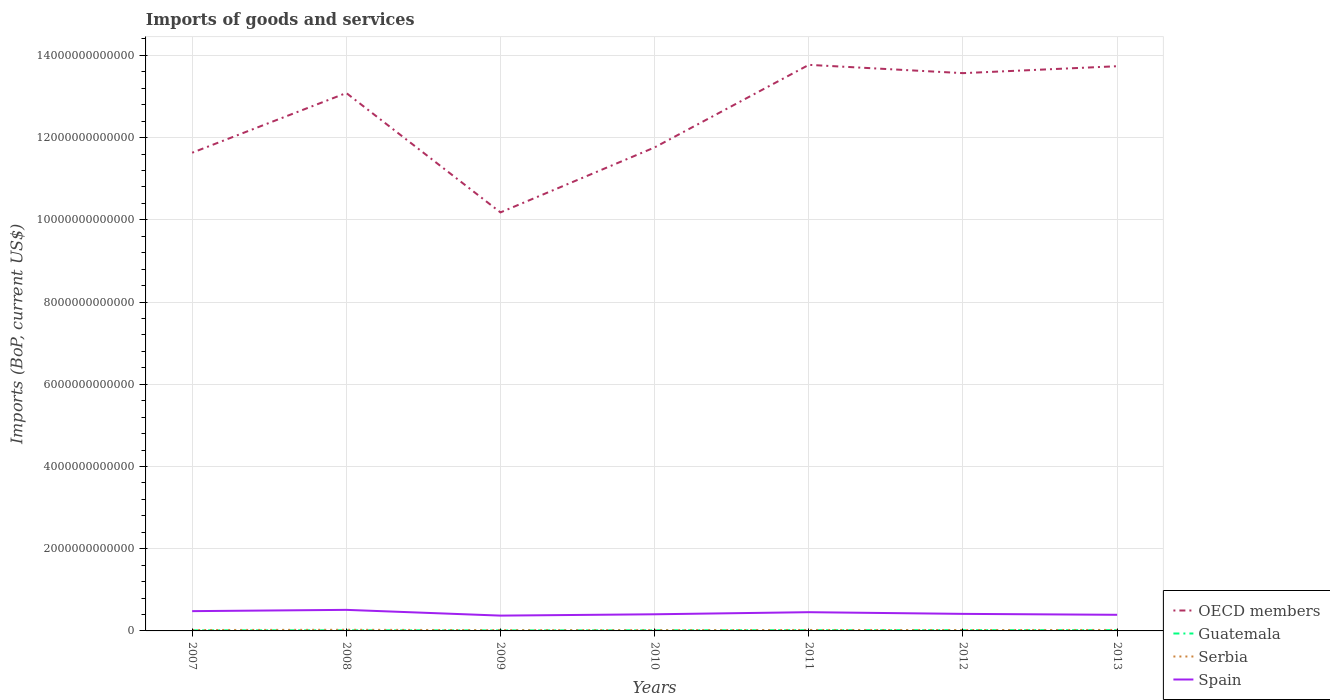Is the number of lines equal to the number of legend labels?
Give a very brief answer. Yes. Across all years, what is the maximum amount spent on imports in Guatemala?
Provide a succinct answer. 1.28e+1. What is the total amount spent on imports in Serbia in the graph?
Give a very brief answer. 2.93e+09. What is the difference between the highest and the second highest amount spent on imports in Spain?
Provide a short and direct response. 1.40e+11. What is the difference between the highest and the lowest amount spent on imports in Guatemala?
Give a very brief answer. 3. Is the amount spent on imports in Serbia strictly greater than the amount spent on imports in Guatemala over the years?
Provide a succinct answer. No. How many lines are there?
Your answer should be compact. 4. How many years are there in the graph?
Provide a succinct answer. 7. What is the difference between two consecutive major ticks on the Y-axis?
Ensure brevity in your answer.  2.00e+12. Are the values on the major ticks of Y-axis written in scientific E-notation?
Give a very brief answer. No. Does the graph contain any zero values?
Ensure brevity in your answer.  No. How are the legend labels stacked?
Give a very brief answer. Vertical. What is the title of the graph?
Your answer should be compact. Imports of goods and services. What is the label or title of the X-axis?
Ensure brevity in your answer.  Years. What is the label or title of the Y-axis?
Offer a terse response. Imports (BoP, current US$). What is the Imports (BoP, current US$) of OECD members in 2007?
Offer a terse response. 1.16e+13. What is the Imports (BoP, current US$) of Guatemala in 2007?
Provide a succinct answer. 1.45e+1. What is the Imports (BoP, current US$) of Serbia in 2007?
Ensure brevity in your answer.  2.19e+1. What is the Imports (BoP, current US$) of Spain in 2007?
Your response must be concise. 4.81e+11. What is the Imports (BoP, current US$) of OECD members in 2008?
Keep it short and to the point. 1.31e+13. What is the Imports (BoP, current US$) of Guatemala in 2008?
Offer a terse response. 1.55e+1. What is the Imports (BoP, current US$) of Serbia in 2008?
Provide a succinct answer. 2.78e+1. What is the Imports (BoP, current US$) of Spain in 2008?
Make the answer very short. 5.12e+11. What is the Imports (BoP, current US$) of OECD members in 2009?
Offer a terse response. 1.02e+13. What is the Imports (BoP, current US$) of Guatemala in 2009?
Provide a short and direct response. 1.28e+1. What is the Imports (BoP, current US$) of Serbia in 2009?
Offer a very short reply. 1.89e+1. What is the Imports (BoP, current US$) in Spain in 2009?
Ensure brevity in your answer.  3.72e+11. What is the Imports (BoP, current US$) of OECD members in 2010?
Offer a terse response. 1.18e+13. What is the Imports (BoP, current US$) of Guatemala in 2010?
Provide a short and direct response. 1.52e+1. What is the Imports (BoP, current US$) of Serbia in 2010?
Ensure brevity in your answer.  1.94e+1. What is the Imports (BoP, current US$) in Spain in 2010?
Your response must be concise. 4.05e+11. What is the Imports (BoP, current US$) of OECD members in 2011?
Offer a very short reply. 1.38e+13. What is the Imports (BoP, current US$) of Guatemala in 2011?
Make the answer very short. 1.80e+1. What is the Imports (BoP, current US$) in Serbia in 2011?
Offer a terse response. 2.31e+1. What is the Imports (BoP, current US$) of Spain in 2011?
Provide a short and direct response. 4.56e+11. What is the Imports (BoP, current US$) in OECD members in 2012?
Make the answer very short. 1.36e+13. What is the Imports (BoP, current US$) of Guatemala in 2012?
Provide a short and direct response. 1.84e+1. What is the Imports (BoP, current US$) of Serbia in 2012?
Your response must be concise. 2.19e+1. What is the Imports (BoP, current US$) in Spain in 2012?
Your response must be concise. 4.15e+11. What is the Imports (BoP, current US$) in OECD members in 2013?
Provide a short and direct response. 1.37e+13. What is the Imports (BoP, current US$) in Guatemala in 2013?
Offer a very short reply. 1.91e+1. What is the Imports (BoP, current US$) of Serbia in 2013?
Your answer should be compact. 2.37e+1. What is the Imports (BoP, current US$) of Spain in 2013?
Provide a succinct answer. 3.92e+11. Across all years, what is the maximum Imports (BoP, current US$) of OECD members?
Ensure brevity in your answer.  1.38e+13. Across all years, what is the maximum Imports (BoP, current US$) of Guatemala?
Your answer should be very brief. 1.91e+1. Across all years, what is the maximum Imports (BoP, current US$) in Serbia?
Your response must be concise. 2.78e+1. Across all years, what is the maximum Imports (BoP, current US$) in Spain?
Your response must be concise. 5.12e+11. Across all years, what is the minimum Imports (BoP, current US$) of OECD members?
Provide a short and direct response. 1.02e+13. Across all years, what is the minimum Imports (BoP, current US$) of Guatemala?
Ensure brevity in your answer.  1.28e+1. Across all years, what is the minimum Imports (BoP, current US$) of Serbia?
Make the answer very short. 1.89e+1. Across all years, what is the minimum Imports (BoP, current US$) of Spain?
Make the answer very short. 3.72e+11. What is the total Imports (BoP, current US$) of OECD members in the graph?
Offer a very short reply. 8.77e+13. What is the total Imports (BoP, current US$) in Guatemala in the graph?
Ensure brevity in your answer.  1.13e+11. What is the total Imports (BoP, current US$) in Serbia in the graph?
Give a very brief answer. 1.57e+11. What is the total Imports (BoP, current US$) of Spain in the graph?
Offer a very short reply. 3.03e+12. What is the difference between the Imports (BoP, current US$) of OECD members in 2007 and that in 2008?
Provide a succinct answer. -1.45e+12. What is the difference between the Imports (BoP, current US$) of Guatemala in 2007 and that in 2008?
Make the answer very short. -9.53e+08. What is the difference between the Imports (BoP, current US$) in Serbia in 2007 and that in 2008?
Provide a short and direct response. -5.88e+09. What is the difference between the Imports (BoP, current US$) in Spain in 2007 and that in 2008?
Provide a succinct answer. -3.09e+1. What is the difference between the Imports (BoP, current US$) of OECD members in 2007 and that in 2009?
Your answer should be very brief. 1.45e+12. What is the difference between the Imports (BoP, current US$) of Guatemala in 2007 and that in 2009?
Offer a very short reply. 1.74e+09. What is the difference between the Imports (BoP, current US$) of Serbia in 2007 and that in 2009?
Give a very brief answer. 2.93e+09. What is the difference between the Imports (BoP, current US$) of Spain in 2007 and that in 2009?
Provide a succinct answer. 1.09e+11. What is the difference between the Imports (BoP, current US$) of OECD members in 2007 and that in 2010?
Your answer should be very brief. -1.30e+11. What is the difference between the Imports (BoP, current US$) of Guatemala in 2007 and that in 2010?
Provide a short and direct response. -7.02e+08. What is the difference between the Imports (BoP, current US$) in Serbia in 2007 and that in 2010?
Provide a succinct answer. 2.47e+09. What is the difference between the Imports (BoP, current US$) in Spain in 2007 and that in 2010?
Provide a succinct answer. 7.66e+1. What is the difference between the Imports (BoP, current US$) in OECD members in 2007 and that in 2011?
Give a very brief answer. -2.14e+12. What is the difference between the Imports (BoP, current US$) in Guatemala in 2007 and that in 2011?
Your response must be concise. -3.49e+09. What is the difference between the Imports (BoP, current US$) in Serbia in 2007 and that in 2011?
Your answer should be compact. -1.24e+09. What is the difference between the Imports (BoP, current US$) in Spain in 2007 and that in 2011?
Provide a short and direct response. 2.55e+1. What is the difference between the Imports (BoP, current US$) of OECD members in 2007 and that in 2012?
Offer a very short reply. -1.94e+12. What is the difference between the Imports (BoP, current US$) in Guatemala in 2007 and that in 2012?
Make the answer very short. -3.87e+09. What is the difference between the Imports (BoP, current US$) in Serbia in 2007 and that in 2012?
Your answer should be compact. 1.40e+07. What is the difference between the Imports (BoP, current US$) in Spain in 2007 and that in 2012?
Offer a terse response. 6.68e+1. What is the difference between the Imports (BoP, current US$) in OECD members in 2007 and that in 2013?
Ensure brevity in your answer.  -2.10e+12. What is the difference between the Imports (BoP, current US$) in Guatemala in 2007 and that in 2013?
Offer a very short reply. -4.60e+09. What is the difference between the Imports (BoP, current US$) of Serbia in 2007 and that in 2013?
Keep it short and to the point. -1.78e+09. What is the difference between the Imports (BoP, current US$) in Spain in 2007 and that in 2013?
Provide a short and direct response. 8.90e+1. What is the difference between the Imports (BoP, current US$) in OECD members in 2008 and that in 2009?
Make the answer very short. 2.90e+12. What is the difference between the Imports (BoP, current US$) in Guatemala in 2008 and that in 2009?
Give a very brief answer. 2.69e+09. What is the difference between the Imports (BoP, current US$) of Serbia in 2008 and that in 2009?
Give a very brief answer. 8.80e+09. What is the difference between the Imports (BoP, current US$) of Spain in 2008 and that in 2009?
Your answer should be compact. 1.40e+11. What is the difference between the Imports (BoP, current US$) of OECD members in 2008 and that in 2010?
Offer a very short reply. 1.32e+12. What is the difference between the Imports (BoP, current US$) in Guatemala in 2008 and that in 2010?
Your answer should be very brief. 2.51e+08. What is the difference between the Imports (BoP, current US$) in Serbia in 2008 and that in 2010?
Offer a very short reply. 8.35e+09. What is the difference between the Imports (BoP, current US$) of Spain in 2008 and that in 2010?
Give a very brief answer. 1.07e+11. What is the difference between the Imports (BoP, current US$) in OECD members in 2008 and that in 2011?
Offer a terse response. -6.85e+11. What is the difference between the Imports (BoP, current US$) in Guatemala in 2008 and that in 2011?
Give a very brief answer. -2.53e+09. What is the difference between the Imports (BoP, current US$) of Serbia in 2008 and that in 2011?
Your answer should be compact. 4.63e+09. What is the difference between the Imports (BoP, current US$) in Spain in 2008 and that in 2011?
Ensure brevity in your answer.  5.64e+1. What is the difference between the Imports (BoP, current US$) in OECD members in 2008 and that in 2012?
Your answer should be compact. -4.83e+11. What is the difference between the Imports (BoP, current US$) of Guatemala in 2008 and that in 2012?
Provide a short and direct response. -2.91e+09. What is the difference between the Imports (BoP, current US$) in Serbia in 2008 and that in 2012?
Your response must be concise. 5.89e+09. What is the difference between the Imports (BoP, current US$) in Spain in 2008 and that in 2012?
Your response must be concise. 9.77e+1. What is the difference between the Imports (BoP, current US$) of OECD members in 2008 and that in 2013?
Make the answer very short. -6.52e+11. What is the difference between the Imports (BoP, current US$) in Guatemala in 2008 and that in 2013?
Provide a succinct answer. -3.65e+09. What is the difference between the Imports (BoP, current US$) of Serbia in 2008 and that in 2013?
Provide a short and direct response. 4.10e+09. What is the difference between the Imports (BoP, current US$) of Spain in 2008 and that in 2013?
Ensure brevity in your answer.  1.20e+11. What is the difference between the Imports (BoP, current US$) in OECD members in 2009 and that in 2010?
Provide a short and direct response. -1.58e+12. What is the difference between the Imports (BoP, current US$) in Guatemala in 2009 and that in 2010?
Offer a very short reply. -2.44e+09. What is the difference between the Imports (BoP, current US$) in Serbia in 2009 and that in 2010?
Keep it short and to the point. -4.57e+08. What is the difference between the Imports (BoP, current US$) of Spain in 2009 and that in 2010?
Your answer should be compact. -3.24e+1. What is the difference between the Imports (BoP, current US$) in OECD members in 2009 and that in 2011?
Your answer should be compact. -3.59e+12. What is the difference between the Imports (BoP, current US$) of Guatemala in 2009 and that in 2011?
Give a very brief answer. -5.22e+09. What is the difference between the Imports (BoP, current US$) in Serbia in 2009 and that in 2011?
Offer a terse response. -4.17e+09. What is the difference between the Imports (BoP, current US$) of Spain in 2009 and that in 2011?
Ensure brevity in your answer.  -8.35e+1. What is the difference between the Imports (BoP, current US$) of OECD members in 2009 and that in 2012?
Make the answer very short. -3.39e+12. What is the difference between the Imports (BoP, current US$) in Guatemala in 2009 and that in 2012?
Offer a very short reply. -5.60e+09. What is the difference between the Imports (BoP, current US$) of Serbia in 2009 and that in 2012?
Keep it short and to the point. -2.91e+09. What is the difference between the Imports (BoP, current US$) of Spain in 2009 and that in 2012?
Provide a short and direct response. -4.21e+1. What is the difference between the Imports (BoP, current US$) of OECD members in 2009 and that in 2013?
Your response must be concise. -3.56e+12. What is the difference between the Imports (BoP, current US$) in Guatemala in 2009 and that in 2013?
Provide a succinct answer. -6.34e+09. What is the difference between the Imports (BoP, current US$) in Serbia in 2009 and that in 2013?
Your answer should be compact. -4.71e+09. What is the difference between the Imports (BoP, current US$) in Spain in 2009 and that in 2013?
Provide a short and direct response. -1.99e+1. What is the difference between the Imports (BoP, current US$) of OECD members in 2010 and that in 2011?
Ensure brevity in your answer.  -2.01e+12. What is the difference between the Imports (BoP, current US$) of Guatemala in 2010 and that in 2011?
Give a very brief answer. -2.79e+09. What is the difference between the Imports (BoP, current US$) of Serbia in 2010 and that in 2011?
Ensure brevity in your answer.  -3.71e+09. What is the difference between the Imports (BoP, current US$) in Spain in 2010 and that in 2011?
Offer a terse response. -5.10e+1. What is the difference between the Imports (BoP, current US$) in OECD members in 2010 and that in 2012?
Make the answer very short. -1.81e+12. What is the difference between the Imports (BoP, current US$) of Guatemala in 2010 and that in 2012?
Your response must be concise. -3.16e+09. What is the difference between the Imports (BoP, current US$) in Serbia in 2010 and that in 2012?
Your answer should be very brief. -2.46e+09. What is the difference between the Imports (BoP, current US$) of Spain in 2010 and that in 2012?
Offer a very short reply. -9.73e+09. What is the difference between the Imports (BoP, current US$) in OECD members in 2010 and that in 2013?
Make the answer very short. -1.97e+12. What is the difference between the Imports (BoP, current US$) in Guatemala in 2010 and that in 2013?
Give a very brief answer. -3.90e+09. What is the difference between the Imports (BoP, current US$) of Serbia in 2010 and that in 2013?
Make the answer very short. -4.25e+09. What is the difference between the Imports (BoP, current US$) in Spain in 2010 and that in 2013?
Keep it short and to the point. 1.25e+1. What is the difference between the Imports (BoP, current US$) in OECD members in 2011 and that in 2012?
Give a very brief answer. 2.02e+11. What is the difference between the Imports (BoP, current US$) of Guatemala in 2011 and that in 2012?
Offer a terse response. -3.78e+08. What is the difference between the Imports (BoP, current US$) in Serbia in 2011 and that in 2012?
Offer a terse response. 1.26e+09. What is the difference between the Imports (BoP, current US$) in Spain in 2011 and that in 2012?
Keep it short and to the point. 4.13e+1. What is the difference between the Imports (BoP, current US$) of OECD members in 2011 and that in 2013?
Offer a very short reply. 3.33e+1. What is the difference between the Imports (BoP, current US$) in Guatemala in 2011 and that in 2013?
Ensure brevity in your answer.  -1.12e+09. What is the difference between the Imports (BoP, current US$) in Serbia in 2011 and that in 2013?
Provide a succinct answer. -5.34e+08. What is the difference between the Imports (BoP, current US$) in Spain in 2011 and that in 2013?
Keep it short and to the point. 6.35e+1. What is the difference between the Imports (BoP, current US$) in OECD members in 2012 and that in 2013?
Ensure brevity in your answer.  -1.68e+11. What is the difference between the Imports (BoP, current US$) in Guatemala in 2012 and that in 2013?
Provide a succinct answer. -7.39e+08. What is the difference between the Imports (BoP, current US$) of Serbia in 2012 and that in 2013?
Your response must be concise. -1.79e+09. What is the difference between the Imports (BoP, current US$) in Spain in 2012 and that in 2013?
Your answer should be compact. 2.22e+1. What is the difference between the Imports (BoP, current US$) of OECD members in 2007 and the Imports (BoP, current US$) of Guatemala in 2008?
Your answer should be compact. 1.16e+13. What is the difference between the Imports (BoP, current US$) in OECD members in 2007 and the Imports (BoP, current US$) in Serbia in 2008?
Make the answer very short. 1.16e+13. What is the difference between the Imports (BoP, current US$) in OECD members in 2007 and the Imports (BoP, current US$) in Spain in 2008?
Keep it short and to the point. 1.11e+13. What is the difference between the Imports (BoP, current US$) in Guatemala in 2007 and the Imports (BoP, current US$) in Serbia in 2008?
Provide a short and direct response. -1.32e+1. What is the difference between the Imports (BoP, current US$) of Guatemala in 2007 and the Imports (BoP, current US$) of Spain in 2008?
Provide a succinct answer. -4.98e+11. What is the difference between the Imports (BoP, current US$) in Serbia in 2007 and the Imports (BoP, current US$) in Spain in 2008?
Your answer should be compact. -4.90e+11. What is the difference between the Imports (BoP, current US$) of OECD members in 2007 and the Imports (BoP, current US$) of Guatemala in 2009?
Give a very brief answer. 1.16e+13. What is the difference between the Imports (BoP, current US$) in OECD members in 2007 and the Imports (BoP, current US$) in Serbia in 2009?
Your answer should be very brief. 1.16e+13. What is the difference between the Imports (BoP, current US$) in OECD members in 2007 and the Imports (BoP, current US$) in Spain in 2009?
Provide a succinct answer. 1.13e+13. What is the difference between the Imports (BoP, current US$) in Guatemala in 2007 and the Imports (BoP, current US$) in Serbia in 2009?
Ensure brevity in your answer.  -4.44e+09. What is the difference between the Imports (BoP, current US$) of Guatemala in 2007 and the Imports (BoP, current US$) of Spain in 2009?
Give a very brief answer. -3.58e+11. What is the difference between the Imports (BoP, current US$) in Serbia in 2007 and the Imports (BoP, current US$) in Spain in 2009?
Ensure brevity in your answer.  -3.51e+11. What is the difference between the Imports (BoP, current US$) of OECD members in 2007 and the Imports (BoP, current US$) of Guatemala in 2010?
Keep it short and to the point. 1.16e+13. What is the difference between the Imports (BoP, current US$) in OECD members in 2007 and the Imports (BoP, current US$) in Serbia in 2010?
Provide a short and direct response. 1.16e+13. What is the difference between the Imports (BoP, current US$) of OECD members in 2007 and the Imports (BoP, current US$) of Spain in 2010?
Your answer should be very brief. 1.12e+13. What is the difference between the Imports (BoP, current US$) of Guatemala in 2007 and the Imports (BoP, current US$) of Serbia in 2010?
Keep it short and to the point. -4.89e+09. What is the difference between the Imports (BoP, current US$) in Guatemala in 2007 and the Imports (BoP, current US$) in Spain in 2010?
Give a very brief answer. -3.90e+11. What is the difference between the Imports (BoP, current US$) in Serbia in 2007 and the Imports (BoP, current US$) in Spain in 2010?
Give a very brief answer. -3.83e+11. What is the difference between the Imports (BoP, current US$) in OECD members in 2007 and the Imports (BoP, current US$) in Guatemala in 2011?
Your answer should be very brief. 1.16e+13. What is the difference between the Imports (BoP, current US$) of OECD members in 2007 and the Imports (BoP, current US$) of Serbia in 2011?
Offer a very short reply. 1.16e+13. What is the difference between the Imports (BoP, current US$) of OECD members in 2007 and the Imports (BoP, current US$) of Spain in 2011?
Provide a succinct answer. 1.12e+13. What is the difference between the Imports (BoP, current US$) of Guatemala in 2007 and the Imports (BoP, current US$) of Serbia in 2011?
Your answer should be compact. -8.61e+09. What is the difference between the Imports (BoP, current US$) of Guatemala in 2007 and the Imports (BoP, current US$) of Spain in 2011?
Provide a succinct answer. -4.41e+11. What is the difference between the Imports (BoP, current US$) in Serbia in 2007 and the Imports (BoP, current US$) in Spain in 2011?
Your response must be concise. -4.34e+11. What is the difference between the Imports (BoP, current US$) in OECD members in 2007 and the Imports (BoP, current US$) in Guatemala in 2012?
Keep it short and to the point. 1.16e+13. What is the difference between the Imports (BoP, current US$) in OECD members in 2007 and the Imports (BoP, current US$) in Serbia in 2012?
Keep it short and to the point. 1.16e+13. What is the difference between the Imports (BoP, current US$) in OECD members in 2007 and the Imports (BoP, current US$) in Spain in 2012?
Provide a succinct answer. 1.12e+13. What is the difference between the Imports (BoP, current US$) of Guatemala in 2007 and the Imports (BoP, current US$) of Serbia in 2012?
Keep it short and to the point. -7.35e+09. What is the difference between the Imports (BoP, current US$) in Guatemala in 2007 and the Imports (BoP, current US$) in Spain in 2012?
Provide a short and direct response. -4.00e+11. What is the difference between the Imports (BoP, current US$) of Serbia in 2007 and the Imports (BoP, current US$) of Spain in 2012?
Offer a terse response. -3.93e+11. What is the difference between the Imports (BoP, current US$) in OECD members in 2007 and the Imports (BoP, current US$) in Guatemala in 2013?
Your answer should be compact. 1.16e+13. What is the difference between the Imports (BoP, current US$) of OECD members in 2007 and the Imports (BoP, current US$) of Serbia in 2013?
Offer a terse response. 1.16e+13. What is the difference between the Imports (BoP, current US$) of OECD members in 2007 and the Imports (BoP, current US$) of Spain in 2013?
Offer a terse response. 1.12e+13. What is the difference between the Imports (BoP, current US$) in Guatemala in 2007 and the Imports (BoP, current US$) in Serbia in 2013?
Your answer should be very brief. -9.14e+09. What is the difference between the Imports (BoP, current US$) of Guatemala in 2007 and the Imports (BoP, current US$) of Spain in 2013?
Your answer should be compact. -3.78e+11. What is the difference between the Imports (BoP, current US$) of Serbia in 2007 and the Imports (BoP, current US$) of Spain in 2013?
Your response must be concise. -3.70e+11. What is the difference between the Imports (BoP, current US$) in OECD members in 2008 and the Imports (BoP, current US$) in Guatemala in 2009?
Make the answer very short. 1.31e+13. What is the difference between the Imports (BoP, current US$) of OECD members in 2008 and the Imports (BoP, current US$) of Serbia in 2009?
Your answer should be very brief. 1.31e+13. What is the difference between the Imports (BoP, current US$) in OECD members in 2008 and the Imports (BoP, current US$) in Spain in 2009?
Your response must be concise. 1.27e+13. What is the difference between the Imports (BoP, current US$) in Guatemala in 2008 and the Imports (BoP, current US$) in Serbia in 2009?
Provide a succinct answer. -3.48e+09. What is the difference between the Imports (BoP, current US$) of Guatemala in 2008 and the Imports (BoP, current US$) of Spain in 2009?
Provide a succinct answer. -3.57e+11. What is the difference between the Imports (BoP, current US$) of Serbia in 2008 and the Imports (BoP, current US$) of Spain in 2009?
Make the answer very short. -3.45e+11. What is the difference between the Imports (BoP, current US$) of OECD members in 2008 and the Imports (BoP, current US$) of Guatemala in 2010?
Offer a terse response. 1.31e+13. What is the difference between the Imports (BoP, current US$) in OECD members in 2008 and the Imports (BoP, current US$) in Serbia in 2010?
Keep it short and to the point. 1.31e+13. What is the difference between the Imports (BoP, current US$) of OECD members in 2008 and the Imports (BoP, current US$) of Spain in 2010?
Keep it short and to the point. 1.27e+13. What is the difference between the Imports (BoP, current US$) of Guatemala in 2008 and the Imports (BoP, current US$) of Serbia in 2010?
Provide a short and direct response. -3.94e+09. What is the difference between the Imports (BoP, current US$) in Guatemala in 2008 and the Imports (BoP, current US$) in Spain in 2010?
Give a very brief answer. -3.89e+11. What is the difference between the Imports (BoP, current US$) in Serbia in 2008 and the Imports (BoP, current US$) in Spain in 2010?
Your response must be concise. -3.77e+11. What is the difference between the Imports (BoP, current US$) in OECD members in 2008 and the Imports (BoP, current US$) in Guatemala in 2011?
Keep it short and to the point. 1.31e+13. What is the difference between the Imports (BoP, current US$) of OECD members in 2008 and the Imports (BoP, current US$) of Serbia in 2011?
Your answer should be very brief. 1.31e+13. What is the difference between the Imports (BoP, current US$) of OECD members in 2008 and the Imports (BoP, current US$) of Spain in 2011?
Your answer should be compact. 1.26e+13. What is the difference between the Imports (BoP, current US$) of Guatemala in 2008 and the Imports (BoP, current US$) of Serbia in 2011?
Make the answer very short. -7.65e+09. What is the difference between the Imports (BoP, current US$) of Guatemala in 2008 and the Imports (BoP, current US$) of Spain in 2011?
Your answer should be very brief. -4.40e+11. What is the difference between the Imports (BoP, current US$) of Serbia in 2008 and the Imports (BoP, current US$) of Spain in 2011?
Ensure brevity in your answer.  -4.28e+11. What is the difference between the Imports (BoP, current US$) in OECD members in 2008 and the Imports (BoP, current US$) in Guatemala in 2012?
Keep it short and to the point. 1.31e+13. What is the difference between the Imports (BoP, current US$) of OECD members in 2008 and the Imports (BoP, current US$) of Serbia in 2012?
Your answer should be very brief. 1.31e+13. What is the difference between the Imports (BoP, current US$) in OECD members in 2008 and the Imports (BoP, current US$) in Spain in 2012?
Your response must be concise. 1.27e+13. What is the difference between the Imports (BoP, current US$) in Guatemala in 2008 and the Imports (BoP, current US$) in Serbia in 2012?
Make the answer very short. -6.40e+09. What is the difference between the Imports (BoP, current US$) in Guatemala in 2008 and the Imports (BoP, current US$) in Spain in 2012?
Give a very brief answer. -3.99e+11. What is the difference between the Imports (BoP, current US$) in Serbia in 2008 and the Imports (BoP, current US$) in Spain in 2012?
Give a very brief answer. -3.87e+11. What is the difference between the Imports (BoP, current US$) of OECD members in 2008 and the Imports (BoP, current US$) of Guatemala in 2013?
Offer a terse response. 1.31e+13. What is the difference between the Imports (BoP, current US$) of OECD members in 2008 and the Imports (BoP, current US$) of Serbia in 2013?
Your answer should be very brief. 1.31e+13. What is the difference between the Imports (BoP, current US$) in OECD members in 2008 and the Imports (BoP, current US$) in Spain in 2013?
Your answer should be very brief. 1.27e+13. What is the difference between the Imports (BoP, current US$) in Guatemala in 2008 and the Imports (BoP, current US$) in Serbia in 2013?
Provide a short and direct response. -8.19e+09. What is the difference between the Imports (BoP, current US$) in Guatemala in 2008 and the Imports (BoP, current US$) in Spain in 2013?
Give a very brief answer. -3.77e+11. What is the difference between the Imports (BoP, current US$) in Serbia in 2008 and the Imports (BoP, current US$) in Spain in 2013?
Offer a terse response. -3.65e+11. What is the difference between the Imports (BoP, current US$) of OECD members in 2009 and the Imports (BoP, current US$) of Guatemala in 2010?
Offer a very short reply. 1.02e+13. What is the difference between the Imports (BoP, current US$) of OECD members in 2009 and the Imports (BoP, current US$) of Serbia in 2010?
Keep it short and to the point. 1.02e+13. What is the difference between the Imports (BoP, current US$) in OECD members in 2009 and the Imports (BoP, current US$) in Spain in 2010?
Ensure brevity in your answer.  9.78e+12. What is the difference between the Imports (BoP, current US$) of Guatemala in 2009 and the Imports (BoP, current US$) of Serbia in 2010?
Offer a very short reply. -6.63e+09. What is the difference between the Imports (BoP, current US$) of Guatemala in 2009 and the Imports (BoP, current US$) of Spain in 2010?
Your response must be concise. -3.92e+11. What is the difference between the Imports (BoP, current US$) in Serbia in 2009 and the Imports (BoP, current US$) in Spain in 2010?
Provide a short and direct response. -3.86e+11. What is the difference between the Imports (BoP, current US$) in OECD members in 2009 and the Imports (BoP, current US$) in Guatemala in 2011?
Ensure brevity in your answer.  1.02e+13. What is the difference between the Imports (BoP, current US$) in OECD members in 2009 and the Imports (BoP, current US$) in Serbia in 2011?
Offer a very short reply. 1.02e+13. What is the difference between the Imports (BoP, current US$) of OECD members in 2009 and the Imports (BoP, current US$) of Spain in 2011?
Your answer should be very brief. 9.72e+12. What is the difference between the Imports (BoP, current US$) of Guatemala in 2009 and the Imports (BoP, current US$) of Serbia in 2011?
Keep it short and to the point. -1.03e+1. What is the difference between the Imports (BoP, current US$) of Guatemala in 2009 and the Imports (BoP, current US$) of Spain in 2011?
Offer a terse response. -4.43e+11. What is the difference between the Imports (BoP, current US$) of Serbia in 2009 and the Imports (BoP, current US$) of Spain in 2011?
Provide a short and direct response. -4.37e+11. What is the difference between the Imports (BoP, current US$) in OECD members in 2009 and the Imports (BoP, current US$) in Guatemala in 2012?
Keep it short and to the point. 1.02e+13. What is the difference between the Imports (BoP, current US$) of OECD members in 2009 and the Imports (BoP, current US$) of Serbia in 2012?
Keep it short and to the point. 1.02e+13. What is the difference between the Imports (BoP, current US$) of OECD members in 2009 and the Imports (BoP, current US$) of Spain in 2012?
Provide a short and direct response. 9.77e+12. What is the difference between the Imports (BoP, current US$) of Guatemala in 2009 and the Imports (BoP, current US$) of Serbia in 2012?
Offer a terse response. -9.09e+09. What is the difference between the Imports (BoP, current US$) of Guatemala in 2009 and the Imports (BoP, current US$) of Spain in 2012?
Give a very brief answer. -4.02e+11. What is the difference between the Imports (BoP, current US$) of Serbia in 2009 and the Imports (BoP, current US$) of Spain in 2012?
Give a very brief answer. -3.96e+11. What is the difference between the Imports (BoP, current US$) in OECD members in 2009 and the Imports (BoP, current US$) in Guatemala in 2013?
Provide a short and direct response. 1.02e+13. What is the difference between the Imports (BoP, current US$) of OECD members in 2009 and the Imports (BoP, current US$) of Serbia in 2013?
Make the answer very short. 1.02e+13. What is the difference between the Imports (BoP, current US$) in OECD members in 2009 and the Imports (BoP, current US$) in Spain in 2013?
Provide a short and direct response. 9.79e+12. What is the difference between the Imports (BoP, current US$) of Guatemala in 2009 and the Imports (BoP, current US$) of Serbia in 2013?
Provide a short and direct response. -1.09e+1. What is the difference between the Imports (BoP, current US$) in Guatemala in 2009 and the Imports (BoP, current US$) in Spain in 2013?
Keep it short and to the point. -3.80e+11. What is the difference between the Imports (BoP, current US$) of Serbia in 2009 and the Imports (BoP, current US$) of Spain in 2013?
Provide a succinct answer. -3.73e+11. What is the difference between the Imports (BoP, current US$) of OECD members in 2010 and the Imports (BoP, current US$) of Guatemala in 2011?
Keep it short and to the point. 1.17e+13. What is the difference between the Imports (BoP, current US$) of OECD members in 2010 and the Imports (BoP, current US$) of Serbia in 2011?
Your answer should be compact. 1.17e+13. What is the difference between the Imports (BoP, current US$) in OECD members in 2010 and the Imports (BoP, current US$) in Spain in 2011?
Offer a very short reply. 1.13e+13. What is the difference between the Imports (BoP, current US$) of Guatemala in 2010 and the Imports (BoP, current US$) of Serbia in 2011?
Offer a very short reply. -7.90e+09. What is the difference between the Imports (BoP, current US$) in Guatemala in 2010 and the Imports (BoP, current US$) in Spain in 2011?
Your response must be concise. -4.41e+11. What is the difference between the Imports (BoP, current US$) in Serbia in 2010 and the Imports (BoP, current US$) in Spain in 2011?
Make the answer very short. -4.36e+11. What is the difference between the Imports (BoP, current US$) of OECD members in 2010 and the Imports (BoP, current US$) of Guatemala in 2012?
Offer a terse response. 1.17e+13. What is the difference between the Imports (BoP, current US$) of OECD members in 2010 and the Imports (BoP, current US$) of Serbia in 2012?
Provide a short and direct response. 1.17e+13. What is the difference between the Imports (BoP, current US$) in OECD members in 2010 and the Imports (BoP, current US$) in Spain in 2012?
Provide a short and direct response. 1.13e+13. What is the difference between the Imports (BoP, current US$) of Guatemala in 2010 and the Imports (BoP, current US$) of Serbia in 2012?
Keep it short and to the point. -6.65e+09. What is the difference between the Imports (BoP, current US$) in Guatemala in 2010 and the Imports (BoP, current US$) in Spain in 2012?
Provide a succinct answer. -3.99e+11. What is the difference between the Imports (BoP, current US$) in Serbia in 2010 and the Imports (BoP, current US$) in Spain in 2012?
Give a very brief answer. -3.95e+11. What is the difference between the Imports (BoP, current US$) in OECD members in 2010 and the Imports (BoP, current US$) in Guatemala in 2013?
Your response must be concise. 1.17e+13. What is the difference between the Imports (BoP, current US$) of OECD members in 2010 and the Imports (BoP, current US$) of Serbia in 2013?
Give a very brief answer. 1.17e+13. What is the difference between the Imports (BoP, current US$) in OECD members in 2010 and the Imports (BoP, current US$) in Spain in 2013?
Your answer should be very brief. 1.14e+13. What is the difference between the Imports (BoP, current US$) in Guatemala in 2010 and the Imports (BoP, current US$) in Serbia in 2013?
Your answer should be compact. -8.44e+09. What is the difference between the Imports (BoP, current US$) of Guatemala in 2010 and the Imports (BoP, current US$) of Spain in 2013?
Ensure brevity in your answer.  -3.77e+11. What is the difference between the Imports (BoP, current US$) of Serbia in 2010 and the Imports (BoP, current US$) of Spain in 2013?
Offer a terse response. -3.73e+11. What is the difference between the Imports (BoP, current US$) of OECD members in 2011 and the Imports (BoP, current US$) of Guatemala in 2012?
Give a very brief answer. 1.38e+13. What is the difference between the Imports (BoP, current US$) of OECD members in 2011 and the Imports (BoP, current US$) of Serbia in 2012?
Offer a terse response. 1.37e+13. What is the difference between the Imports (BoP, current US$) in OECD members in 2011 and the Imports (BoP, current US$) in Spain in 2012?
Offer a terse response. 1.34e+13. What is the difference between the Imports (BoP, current US$) of Guatemala in 2011 and the Imports (BoP, current US$) of Serbia in 2012?
Your answer should be compact. -3.86e+09. What is the difference between the Imports (BoP, current US$) in Guatemala in 2011 and the Imports (BoP, current US$) in Spain in 2012?
Give a very brief answer. -3.97e+11. What is the difference between the Imports (BoP, current US$) of Serbia in 2011 and the Imports (BoP, current US$) of Spain in 2012?
Offer a terse response. -3.91e+11. What is the difference between the Imports (BoP, current US$) of OECD members in 2011 and the Imports (BoP, current US$) of Guatemala in 2013?
Your answer should be compact. 1.38e+13. What is the difference between the Imports (BoP, current US$) of OECD members in 2011 and the Imports (BoP, current US$) of Serbia in 2013?
Offer a very short reply. 1.37e+13. What is the difference between the Imports (BoP, current US$) of OECD members in 2011 and the Imports (BoP, current US$) of Spain in 2013?
Offer a very short reply. 1.34e+13. What is the difference between the Imports (BoP, current US$) in Guatemala in 2011 and the Imports (BoP, current US$) in Serbia in 2013?
Offer a very short reply. -5.65e+09. What is the difference between the Imports (BoP, current US$) of Guatemala in 2011 and the Imports (BoP, current US$) of Spain in 2013?
Provide a short and direct response. -3.74e+11. What is the difference between the Imports (BoP, current US$) in Serbia in 2011 and the Imports (BoP, current US$) in Spain in 2013?
Your response must be concise. -3.69e+11. What is the difference between the Imports (BoP, current US$) in OECD members in 2012 and the Imports (BoP, current US$) in Guatemala in 2013?
Give a very brief answer. 1.35e+13. What is the difference between the Imports (BoP, current US$) of OECD members in 2012 and the Imports (BoP, current US$) of Serbia in 2013?
Offer a very short reply. 1.35e+13. What is the difference between the Imports (BoP, current US$) in OECD members in 2012 and the Imports (BoP, current US$) in Spain in 2013?
Provide a succinct answer. 1.32e+13. What is the difference between the Imports (BoP, current US$) in Guatemala in 2012 and the Imports (BoP, current US$) in Serbia in 2013?
Provide a succinct answer. -5.28e+09. What is the difference between the Imports (BoP, current US$) in Guatemala in 2012 and the Imports (BoP, current US$) in Spain in 2013?
Offer a terse response. -3.74e+11. What is the difference between the Imports (BoP, current US$) in Serbia in 2012 and the Imports (BoP, current US$) in Spain in 2013?
Your response must be concise. -3.70e+11. What is the average Imports (BoP, current US$) of OECD members per year?
Provide a short and direct response. 1.25e+13. What is the average Imports (BoP, current US$) of Guatemala per year?
Your answer should be very brief. 1.62e+1. What is the average Imports (BoP, current US$) of Serbia per year?
Ensure brevity in your answer.  2.24e+1. What is the average Imports (BoP, current US$) of Spain per year?
Keep it short and to the point. 4.33e+11. In the year 2007, what is the difference between the Imports (BoP, current US$) in OECD members and Imports (BoP, current US$) in Guatemala?
Keep it short and to the point. 1.16e+13. In the year 2007, what is the difference between the Imports (BoP, current US$) in OECD members and Imports (BoP, current US$) in Serbia?
Offer a terse response. 1.16e+13. In the year 2007, what is the difference between the Imports (BoP, current US$) in OECD members and Imports (BoP, current US$) in Spain?
Provide a short and direct response. 1.12e+13. In the year 2007, what is the difference between the Imports (BoP, current US$) in Guatemala and Imports (BoP, current US$) in Serbia?
Make the answer very short. -7.36e+09. In the year 2007, what is the difference between the Imports (BoP, current US$) of Guatemala and Imports (BoP, current US$) of Spain?
Give a very brief answer. -4.67e+11. In the year 2007, what is the difference between the Imports (BoP, current US$) in Serbia and Imports (BoP, current US$) in Spain?
Provide a succinct answer. -4.59e+11. In the year 2008, what is the difference between the Imports (BoP, current US$) in OECD members and Imports (BoP, current US$) in Guatemala?
Ensure brevity in your answer.  1.31e+13. In the year 2008, what is the difference between the Imports (BoP, current US$) in OECD members and Imports (BoP, current US$) in Serbia?
Give a very brief answer. 1.31e+13. In the year 2008, what is the difference between the Imports (BoP, current US$) in OECD members and Imports (BoP, current US$) in Spain?
Offer a very short reply. 1.26e+13. In the year 2008, what is the difference between the Imports (BoP, current US$) of Guatemala and Imports (BoP, current US$) of Serbia?
Ensure brevity in your answer.  -1.23e+1. In the year 2008, what is the difference between the Imports (BoP, current US$) in Guatemala and Imports (BoP, current US$) in Spain?
Your answer should be compact. -4.97e+11. In the year 2008, what is the difference between the Imports (BoP, current US$) in Serbia and Imports (BoP, current US$) in Spain?
Ensure brevity in your answer.  -4.84e+11. In the year 2009, what is the difference between the Imports (BoP, current US$) in OECD members and Imports (BoP, current US$) in Guatemala?
Offer a very short reply. 1.02e+13. In the year 2009, what is the difference between the Imports (BoP, current US$) of OECD members and Imports (BoP, current US$) of Serbia?
Give a very brief answer. 1.02e+13. In the year 2009, what is the difference between the Imports (BoP, current US$) in OECD members and Imports (BoP, current US$) in Spain?
Give a very brief answer. 9.81e+12. In the year 2009, what is the difference between the Imports (BoP, current US$) in Guatemala and Imports (BoP, current US$) in Serbia?
Keep it short and to the point. -6.17e+09. In the year 2009, what is the difference between the Imports (BoP, current US$) of Guatemala and Imports (BoP, current US$) of Spain?
Ensure brevity in your answer.  -3.60e+11. In the year 2009, what is the difference between the Imports (BoP, current US$) in Serbia and Imports (BoP, current US$) in Spain?
Keep it short and to the point. -3.53e+11. In the year 2010, what is the difference between the Imports (BoP, current US$) of OECD members and Imports (BoP, current US$) of Guatemala?
Offer a very short reply. 1.17e+13. In the year 2010, what is the difference between the Imports (BoP, current US$) of OECD members and Imports (BoP, current US$) of Serbia?
Your answer should be very brief. 1.17e+13. In the year 2010, what is the difference between the Imports (BoP, current US$) of OECD members and Imports (BoP, current US$) of Spain?
Give a very brief answer. 1.14e+13. In the year 2010, what is the difference between the Imports (BoP, current US$) in Guatemala and Imports (BoP, current US$) in Serbia?
Give a very brief answer. -4.19e+09. In the year 2010, what is the difference between the Imports (BoP, current US$) in Guatemala and Imports (BoP, current US$) in Spain?
Your answer should be compact. -3.90e+11. In the year 2010, what is the difference between the Imports (BoP, current US$) in Serbia and Imports (BoP, current US$) in Spain?
Keep it short and to the point. -3.85e+11. In the year 2011, what is the difference between the Imports (BoP, current US$) in OECD members and Imports (BoP, current US$) in Guatemala?
Keep it short and to the point. 1.38e+13. In the year 2011, what is the difference between the Imports (BoP, current US$) of OECD members and Imports (BoP, current US$) of Serbia?
Offer a very short reply. 1.37e+13. In the year 2011, what is the difference between the Imports (BoP, current US$) of OECD members and Imports (BoP, current US$) of Spain?
Your answer should be compact. 1.33e+13. In the year 2011, what is the difference between the Imports (BoP, current US$) in Guatemala and Imports (BoP, current US$) in Serbia?
Your answer should be compact. -5.12e+09. In the year 2011, what is the difference between the Imports (BoP, current US$) in Guatemala and Imports (BoP, current US$) in Spain?
Your answer should be compact. -4.38e+11. In the year 2011, what is the difference between the Imports (BoP, current US$) in Serbia and Imports (BoP, current US$) in Spain?
Your answer should be compact. -4.33e+11. In the year 2012, what is the difference between the Imports (BoP, current US$) in OECD members and Imports (BoP, current US$) in Guatemala?
Provide a short and direct response. 1.35e+13. In the year 2012, what is the difference between the Imports (BoP, current US$) in OECD members and Imports (BoP, current US$) in Serbia?
Offer a very short reply. 1.35e+13. In the year 2012, what is the difference between the Imports (BoP, current US$) of OECD members and Imports (BoP, current US$) of Spain?
Your answer should be compact. 1.32e+13. In the year 2012, what is the difference between the Imports (BoP, current US$) of Guatemala and Imports (BoP, current US$) of Serbia?
Provide a succinct answer. -3.48e+09. In the year 2012, what is the difference between the Imports (BoP, current US$) in Guatemala and Imports (BoP, current US$) in Spain?
Offer a very short reply. -3.96e+11. In the year 2012, what is the difference between the Imports (BoP, current US$) of Serbia and Imports (BoP, current US$) of Spain?
Your response must be concise. -3.93e+11. In the year 2013, what is the difference between the Imports (BoP, current US$) of OECD members and Imports (BoP, current US$) of Guatemala?
Your answer should be very brief. 1.37e+13. In the year 2013, what is the difference between the Imports (BoP, current US$) of OECD members and Imports (BoP, current US$) of Serbia?
Your answer should be compact. 1.37e+13. In the year 2013, what is the difference between the Imports (BoP, current US$) of OECD members and Imports (BoP, current US$) of Spain?
Your answer should be compact. 1.33e+13. In the year 2013, what is the difference between the Imports (BoP, current US$) in Guatemala and Imports (BoP, current US$) in Serbia?
Give a very brief answer. -4.54e+09. In the year 2013, what is the difference between the Imports (BoP, current US$) of Guatemala and Imports (BoP, current US$) of Spain?
Give a very brief answer. -3.73e+11. In the year 2013, what is the difference between the Imports (BoP, current US$) in Serbia and Imports (BoP, current US$) in Spain?
Your answer should be very brief. -3.69e+11. What is the ratio of the Imports (BoP, current US$) in OECD members in 2007 to that in 2008?
Your answer should be compact. 0.89. What is the ratio of the Imports (BoP, current US$) of Guatemala in 2007 to that in 2008?
Your answer should be compact. 0.94. What is the ratio of the Imports (BoP, current US$) in Serbia in 2007 to that in 2008?
Ensure brevity in your answer.  0.79. What is the ratio of the Imports (BoP, current US$) of Spain in 2007 to that in 2008?
Your answer should be compact. 0.94. What is the ratio of the Imports (BoP, current US$) in OECD members in 2007 to that in 2009?
Make the answer very short. 1.14. What is the ratio of the Imports (BoP, current US$) of Guatemala in 2007 to that in 2009?
Offer a very short reply. 1.14. What is the ratio of the Imports (BoP, current US$) in Serbia in 2007 to that in 2009?
Offer a terse response. 1.15. What is the ratio of the Imports (BoP, current US$) of Spain in 2007 to that in 2009?
Your response must be concise. 1.29. What is the ratio of the Imports (BoP, current US$) in OECD members in 2007 to that in 2010?
Provide a succinct answer. 0.99. What is the ratio of the Imports (BoP, current US$) of Guatemala in 2007 to that in 2010?
Give a very brief answer. 0.95. What is the ratio of the Imports (BoP, current US$) of Serbia in 2007 to that in 2010?
Your response must be concise. 1.13. What is the ratio of the Imports (BoP, current US$) of Spain in 2007 to that in 2010?
Provide a short and direct response. 1.19. What is the ratio of the Imports (BoP, current US$) of OECD members in 2007 to that in 2011?
Provide a short and direct response. 0.84. What is the ratio of the Imports (BoP, current US$) of Guatemala in 2007 to that in 2011?
Your answer should be compact. 0.81. What is the ratio of the Imports (BoP, current US$) of Serbia in 2007 to that in 2011?
Your answer should be very brief. 0.95. What is the ratio of the Imports (BoP, current US$) in Spain in 2007 to that in 2011?
Make the answer very short. 1.06. What is the ratio of the Imports (BoP, current US$) in OECD members in 2007 to that in 2012?
Provide a short and direct response. 0.86. What is the ratio of the Imports (BoP, current US$) in Guatemala in 2007 to that in 2012?
Offer a terse response. 0.79. What is the ratio of the Imports (BoP, current US$) of Serbia in 2007 to that in 2012?
Your answer should be compact. 1. What is the ratio of the Imports (BoP, current US$) in Spain in 2007 to that in 2012?
Your response must be concise. 1.16. What is the ratio of the Imports (BoP, current US$) of OECD members in 2007 to that in 2013?
Your answer should be compact. 0.85. What is the ratio of the Imports (BoP, current US$) of Guatemala in 2007 to that in 2013?
Your answer should be very brief. 0.76. What is the ratio of the Imports (BoP, current US$) of Serbia in 2007 to that in 2013?
Provide a succinct answer. 0.92. What is the ratio of the Imports (BoP, current US$) of Spain in 2007 to that in 2013?
Offer a terse response. 1.23. What is the ratio of the Imports (BoP, current US$) in OECD members in 2008 to that in 2009?
Provide a succinct answer. 1.29. What is the ratio of the Imports (BoP, current US$) of Guatemala in 2008 to that in 2009?
Offer a very short reply. 1.21. What is the ratio of the Imports (BoP, current US$) of Serbia in 2008 to that in 2009?
Ensure brevity in your answer.  1.46. What is the ratio of the Imports (BoP, current US$) in Spain in 2008 to that in 2009?
Provide a short and direct response. 1.38. What is the ratio of the Imports (BoP, current US$) in OECD members in 2008 to that in 2010?
Provide a short and direct response. 1.11. What is the ratio of the Imports (BoP, current US$) of Guatemala in 2008 to that in 2010?
Ensure brevity in your answer.  1.02. What is the ratio of the Imports (BoP, current US$) of Serbia in 2008 to that in 2010?
Make the answer very short. 1.43. What is the ratio of the Imports (BoP, current US$) of Spain in 2008 to that in 2010?
Ensure brevity in your answer.  1.27. What is the ratio of the Imports (BoP, current US$) in OECD members in 2008 to that in 2011?
Provide a succinct answer. 0.95. What is the ratio of the Imports (BoP, current US$) in Guatemala in 2008 to that in 2011?
Your answer should be very brief. 0.86. What is the ratio of the Imports (BoP, current US$) in Serbia in 2008 to that in 2011?
Make the answer very short. 1.2. What is the ratio of the Imports (BoP, current US$) of Spain in 2008 to that in 2011?
Give a very brief answer. 1.12. What is the ratio of the Imports (BoP, current US$) in OECD members in 2008 to that in 2012?
Make the answer very short. 0.96. What is the ratio of the Imports (BoP, current US$) of Guatemala in 2008 to that in 2012?
Provide a succinct answer. 0.84. What is the ratio of the Imports (BoP, current US$) in Serbia in 2008 to that in 2012?
Your response must be concise. 1.27. What is the ratio of the Imports (BoP, current US$) of Spain in 2008 to that in 2012?
Provide a short and direct response. 1.24. What is the ratio of the Imports (BoP, current US$) of OECD members in 2008 to that in 2013?
Offer a terse response. 0.95. What is the ratio of the Imports (BoP, current US$) of Guatemala in 2008 to that in 2013?
Provide a succinct answer. 0.81. What is the ratio of the Imports (BoP, current US$) of Serbia in 2008 to that in 2013?
Make the answer very short. 1.17. What is the ratio of the Imports (BoP, current US$) of Spain in 2008 to that in 2013?
Your answer should be very brief. 1.31. What is the ratio of the Imports (BoP, current US$) of OECD members in 2009 to that in 2010?
Make the answer very short. 0.87. What is the ratio of the Imports (BoP, current US$) in Guatemala in 2009 to that in 2010?
Provide a short and direct response. 0.84. What is the ratio of the Imports (BoP, current US$) in Serbia in 2009 to that in 2010?
Keep it short and to the point. 0.98. What is the ratio of the Imports (BoP, current US$) in Spain in 2009 to that in 2010?
Make the answer very short. 0.92. What is the ratio of the Imports (BoP, current US$) in OECD members in 2009 to that in 2011?
Your answer should be compact. 0.74. What is the ratio of the Imports (BoP, current US$) in Guatemala in 2009 to that in 2011?
Offer a very short reply. 0.71. What is the ratio of the Imports (BoP, current US$) in Serbia in 2009 to that in 2011?
Ensure brevity in your answer.  0.82. What is the ratio of the Imports (BoP, current US$) of Spain in 2009 to that in 2011?
Give a very brief answer. 0.82. What is the ratio of the Imports (BoP, current US$) in OECD members in 2009 to that in 2012?
Provide a succinct answer. 0.75. What is the ratio of the Imports (BoP, current US$) in Guatemala in 2009 to that in 2012?
Your answer should be compact. 0.7. What is the ratio of the Imports (BoP, current US$) of Serbia in 2009 to that in 2012?
Keep it short and to the point. 0.87. What is the ratio of the Imports (BoP, current US$) in Spain in 2009 to that in 2012?
Keep it short and to the point. 0.9. What is the ratio of the Imports (BoP, current US$) in OECD members in 2009 to that in 2013?
Ensure brevity in your answer.  0.74. What is the ratio of the Imports (BoP, current US$) in Guatemala in 2009 to that in 2013?
Provide a succinct answer. 0.67. What is the ratio of the Imports (BoP, current US$) of Serbia in 2009 to that in 2013?
Keep it short and to the point. 0.8. What is the ratio of the Imports (BoP, current US$) in Spain in 2009 to that in 2013?
Your answer should be compact. 0.95. What is the ratio of the Imports (BoP, current US$) of OECD members in 2010 to that in 2011?
Give a very brief answer. 0.85. What is the ratio of the Imports (BoP, current US$) of Guatemala in 2010 to that in 2011?
Ensure brevity in your answer.  0.85. What is the ratio of the Imports (BoP, current US$) of Serbia in 2010 to that in 2011?
Your response must be concise. 0.84. What is the ratio of the Imports (BoP, current US$) of Spain in 2010 to that in 2011?
Provide a short and direct response. 0.89. What is the ratio of the Imports (BoP, current US$) in OECD members in 2010 to that in 2012?
Provide a succinct answer. 0.87. What is the ratio of the Imports (BoP, current US$) in Guatemala in 2010 to that in 2012?
Offer a terse response. 0.83. What is the ratio of the Imports (BoP, current US$) of Serbia in 2010 to that in 2012?
Offer a very short reply. 0.89. What is the ratio of the Imports (BoP, current US$) of Spain in 2010 to that in 2012?
Provide a succinct answer. 0.98. What is the ratio of the Imports (BoP, current US$) in OECD members in 2010 to that in 2013?
Provide a succinct answer. 0.86. What is the ratio of the Imports (BoP, current US$) of Guatemala in 2010 to that in 2013?
Give a very brief answer. 0.8. What is the ratio of the Imports (BoP, current US$) of Serbia in 2010 to that in 2013?
Make the answer very short. 0.82. What is the ratio of the Imports (BoP, current US$) in Spain in 2010 to that in 2013?
Provide a succinct answer. 1.03. What is the ratio of the Imports (BoP, current US$) of OECD members in 2011 to that in 2012?
Provide a succinct answer. 1.01. What is the ratio of the Imports (BoP, current US$) in Guatemala in 2011 to that in 2012?
Provide a short and direct response. 0.98. What is the ratio of the Imports (BoP, current US$) in Serbia in 2011 to that in 2012?
Offer a terse response. 1.06. What is the ratio of the Imports (BoP, current US$) in Spain in 2011 to that in 2012?
Give a very brief answer. 1.1. What is the ratio of the Imports (BoP, current US$) of Guatemala in 2011 to that in 2013?
Make the answer very short. 0.94. What is the ratio of the Imports (BoP, current US$) in Serbia in 2011 to that in 2013?
Your answer should be compact. 0.98. What is the ratio of the Imports (BoP, current US$) in Spain in 2011 to that in 2013?
Your answer should be compact. 1.16. What is the ratio of the Imports (BoP, current US$) in OECD members in 2012 to that in 2013?
Offer a terse response. 0.99. What is the ratio of the Imports (BoP, current US$) in Guatemala in 2012 to that in 2013?
Your answer should be very brief. 0.96. What is the ratio of the Imports (BoP, current US$) in Serbia in 2012 to that in 2013?
Offer a very short reply. 0.92. What is the ratio of the Imports (BoP, current US$) of Spain in 2012 to that in 2013?
Provide a short and direct response. 1.06. What is the difference between the highest and the second highest Imports (BoP, current US$) of OECD members?
Make the answer very short. 3.33e+1. What is the difference between the highest and the second highest Imports (BoP, current US$) in Guatemala?
Offer a terse response. 7.39e+08. What is the difference between the highest and the second highest Imports (BoP, current US$) in Serbia?
Keep it short and to the point. 4.10e+09. What is the difference between the highest and the second highest Imports (BoP, current US$) in Spain?
Give a very brief answer. 3.09e+1. What is the difference between the highest and the lowest Imports (BoP, current US$) in OECD members?
Your response must be concise. 3.59e+12. What is the difference between the highest and the lowest Imports (BoP, current US$) of Guatemala?
Your answer should be very brief. 6.34e+09. What is the difference between the highest and the lowest Imports (BoP, current US$) of Serbia?
Give a very brief answer. 8.80e+09. What is the difference between the highest and the lowest Imports (BoP, current US$) in Spain?
Provide a short and direct response. 1.40e+11. 